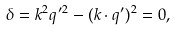<formula> <loc_0><loc_0><loc_500><loc_500>\delta = { k } ^ { 2 } { q } ^ { \, \prime 2 } - ( { k } \cdot { q } ^ { \prime } ) ^ { 2 } = 0 ,</formula> 